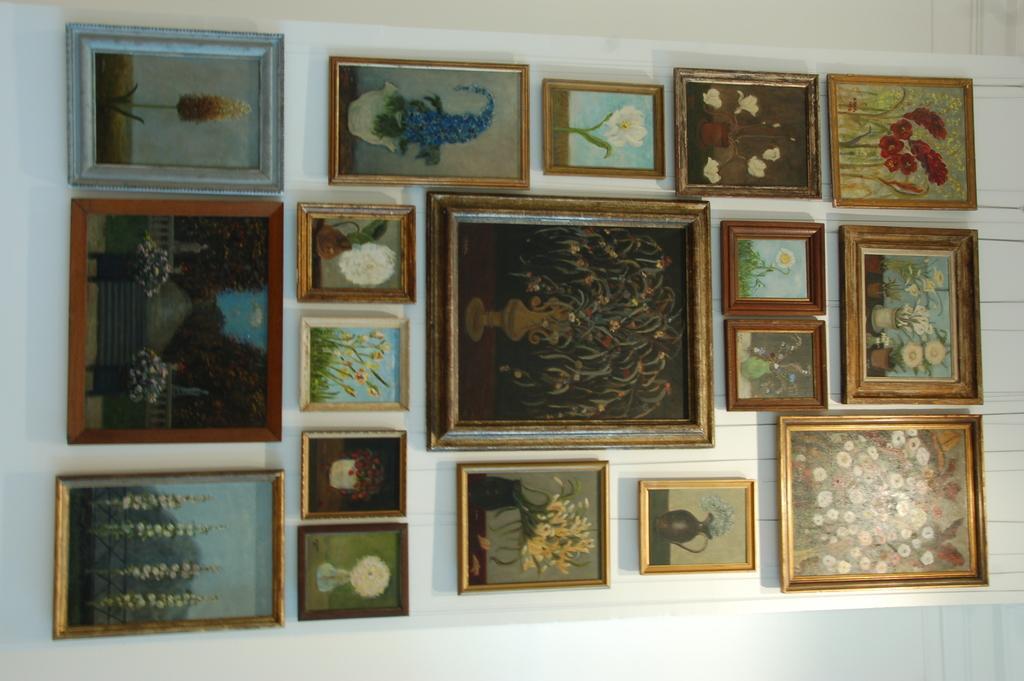Describe this image in one or two sentences. In this image we can see photo frames to the wall. 